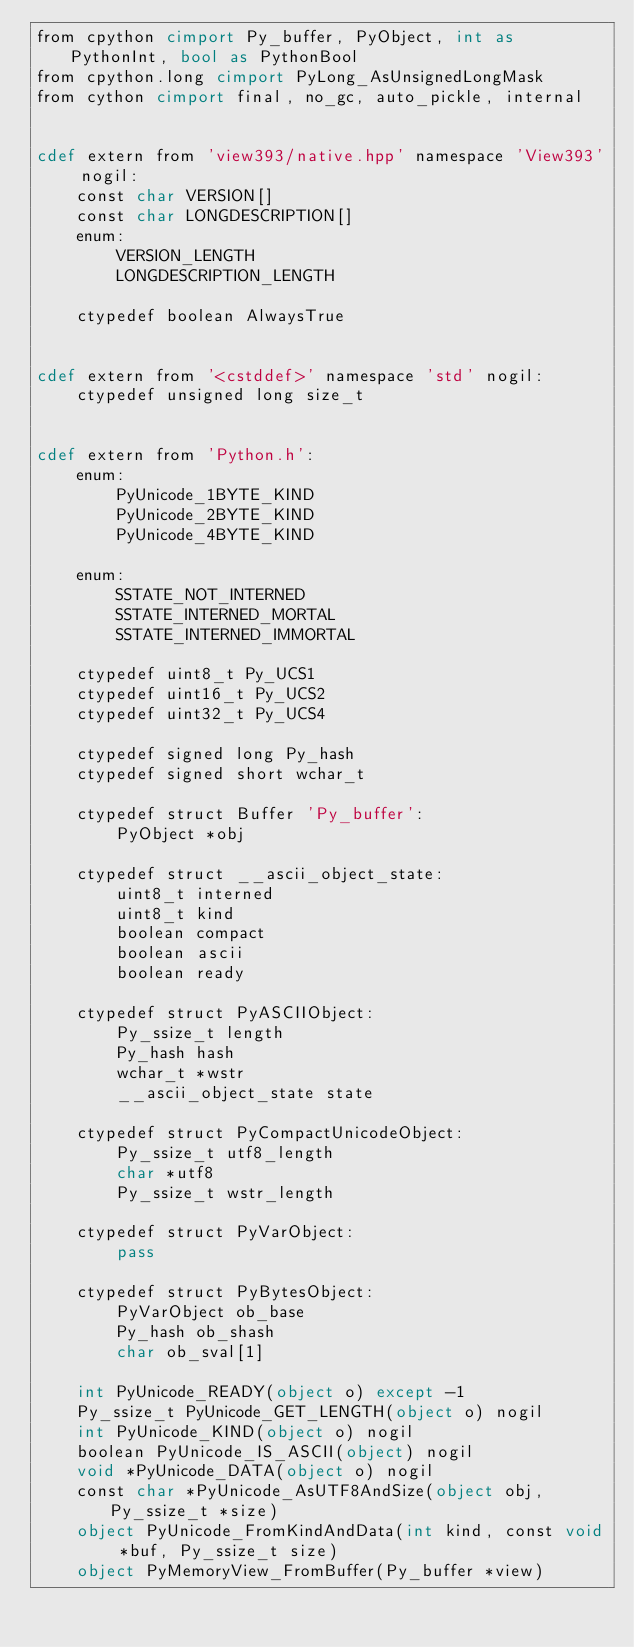Convert code to text. <code><loc_0><loc_0><loc_500><loc_500><_Cython_>from cpython cimport Py_buffer, PyObject, int as PythonInt, bool as PythonBool
from cpython.long cimport PyLong_AsUnsignedLongMask
from cython cimport final, no_gc, auto_pickle, internal


cdef extern from 'view393/native.hpp' namespace 'View393' nogil:
    const char VERSION[]
    const char LONGDESCRIPTION[]
    enum:
        VERSION_LENGTH
        LONGDESCRIPTION_LENGTH

    ctypedef boolean AlwaysTrue


cdef extern from '<cstddef>' namespace 'std' nogil:
    ctypedef unsigned long size_t


cdef extern from 'Python.h':
    enum:
        PyUnicode_1BYTE_KIND
        PyUnicode_2BYTE_KIND
        PyUnicode_4BYTE_KIND

    enum:
        SSTATE_NOT_INTERNED
        SSTATE_INTERNED_MORTAL
        SSTATE_INTERNED_IMMORTAL

    ctypedef uint8_t Py_UCS1
    ctypedef uint16_t Py_UCS2
    ctypedef uint32_t Py_UCS4

    ctypedef signed long Py_hash
    ctypedef signed short wchar_t

    ctypedef struct Buffer 'Py_buffer':
        PyObject *obj

    ctypedef struct __ascii_object_state:
        uint8_t interned
        uint8_t kind
        boolean compact
        boolean ascii
        boolean ready

    ctypedef struct PyASCIIObject:
        Py_ssize_t length
        Py_hash hash
        wchar_t *wstr
        __ascii_object_state state

    ctypedef struct PyCompactUnicodeObject:
        Py_ssize_t utf8_length
        char *utf8
        Py_ssize_t wstr_length

    ctypedef struct PyVarObject:
        pass

    ctypedef struct PyBytesObject:
        PyVarObject ob_base
        Py_hash ob_shash
        char ob_sval[1]

    int PyUnicode_READY(object o) except -1
    Py_ssize_t PyUnicode_GET_LENGTH(object o) nogil
    int PyUnicode_KIND(object o) nogil
    boolean PyUnicode_IS_ASCII(object) nogil
    void *PyUnicode_DATA(object o) nogil
    const char *PyUnicode_AsUTF8AndSize(object obj, Py_ssize_t *size)
    object PyUnicode_FromKindAndData(int kind, const void *buf, Py_ssize_t size)
    object PyMemoryView_FromBuffer(Py_buffer *view)</code> 